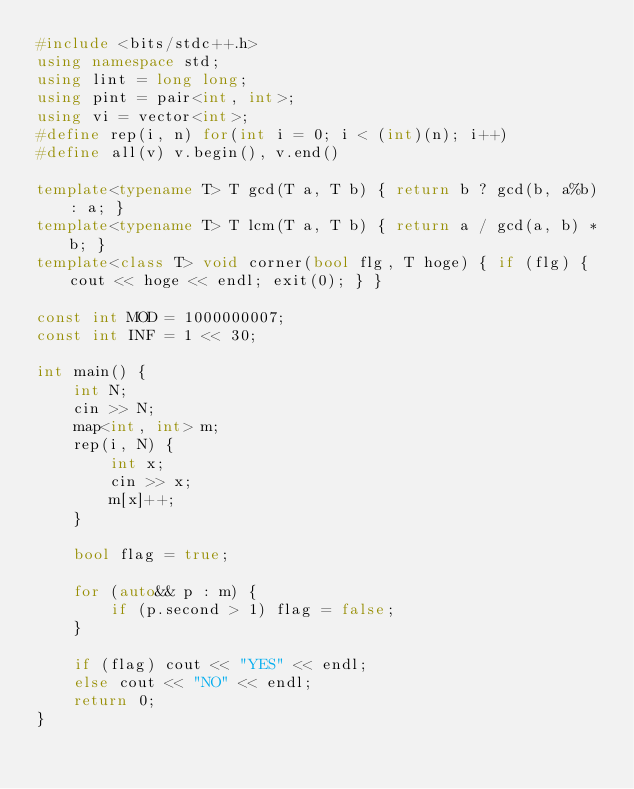Convert code to text. <code><loc_0><loc_0><loc_500><loc_500><_C++_>#include <bits/stdc++.h>
using namespace std;
using lint = long long;
using pint = pair<int, int>;
using vi = vector<int>;
#define rep(i, n) for(int i = 0; i < (int)(n); i++)
#define all(v) v.begin(), v.end()

template<typename T> T gcd(T a, T b) { return b ? gcd(b, a%b) : a; }
template<typename T> T lcm(T a, T b) { return a / gcd(a, b) * b; }
template<class T> void corner(bool flg, T hoge) { if (flg) { cout << hoge << endl; exit(0); } }

const int MOD = 1000000007;
const int INF = 1 << 30;

int main() {
    int N;
    cin >> N;
    map<int, int> m;
    rep(i, N) {
        int x;
        cin >> x;
        m[x]++;
    }

    bool flag = true;

    for (auto&& p : m) {
        if (p.second > 1) flag = false;
    }

    if (flag) cout << "YES" << endl;
    else cout << "NO" << endl;
    return 0;
}
</code> 